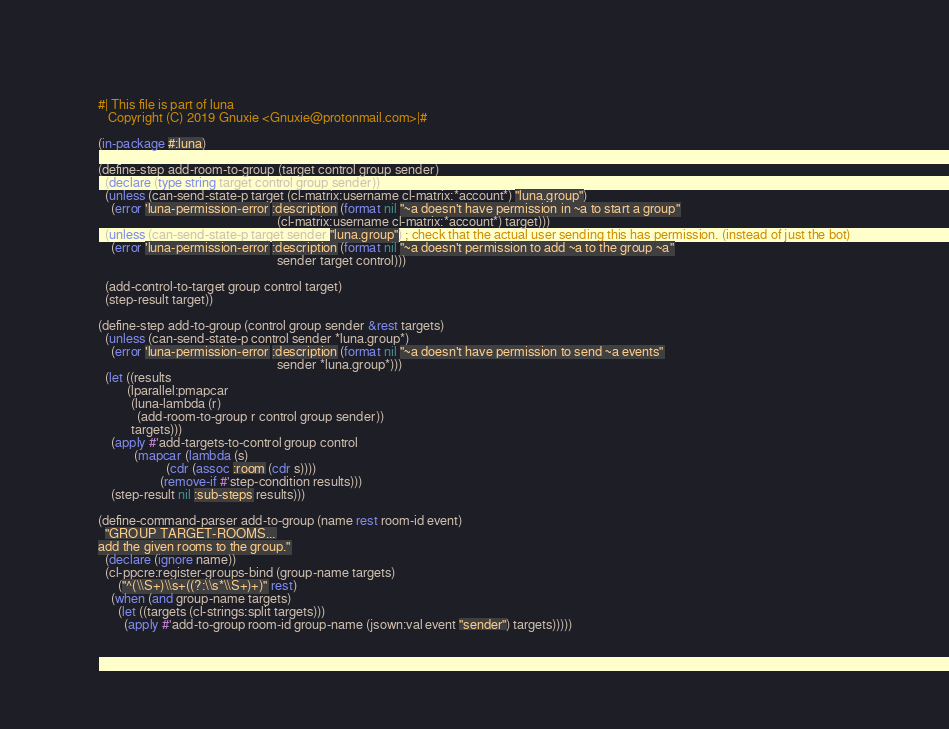Convert code to text. <code><loc_0><loc_0><loc_500><loc_500><_Lisp_>#| This file is part of luna
   Copyright (C) 2019 Gnuxie <Gnuxie@protonmail.com>|#

(in-package #:luna)

(define-step add-room-to-group (target control group sender)
  (declare (type string target control group sender))
  (unless (can-send-state-p target (cl-matrix:username cl-matrix:*account*) "luna.group")
    (error 'luna-permission-error :description (format nil "~a doesn't have permission in ~a to start a group"
                                                       (cl-matrix:username cl-matrix:*account*) target)))
  (unless (can-send-state-p target sender "luna.group") ; check that the actual user sending this has permission. (instead of just the bot)
    (error 'luna-permission-error :description (format nil "~a doesn't permission to add ~a to the group ~a"
                                                       sender target control)))

  (add-control-to-target group control target)
  (step-result target))

(define-step add-to-group (control group sender &rest targets)
  (unless (can-send-state-p control sender *luna.group*)
    (error 'luna-permission-error :description (format nil "~a doesn't have permission to send ~a events"
                                                       sender *luna.group*)))
  (let ((results
         (lparallel:pmapcar
          (luna-lambda (r)
            (add-room-to-group r control group sender))
          targets)))
    (apply #'add-targets-to-control group control
           (mapcar (lambda (s)
                     (cdr (assoc :room (cdr s))))
                   (remove-if #'step-condition results)))
    (step-result nil :sub-steps results)))

(define-command-parser add-to-group (name rest room-id event)
  "GROUP TARGET-ROOMS...
add the given rooms to the group."
  (declare (ignore name))
  (cl-ppcre:register-groups-bind (group-name targets)
      ("^(\\S+)\\s+((?:\\s*\\S+)+)" rest)
    (when (and group-name targets)
      (let ((targets (cl-strings:split targets)))
        (apply #'add-to-group room-id group-name (jsown:val event "sender") targets)))))
</code> 